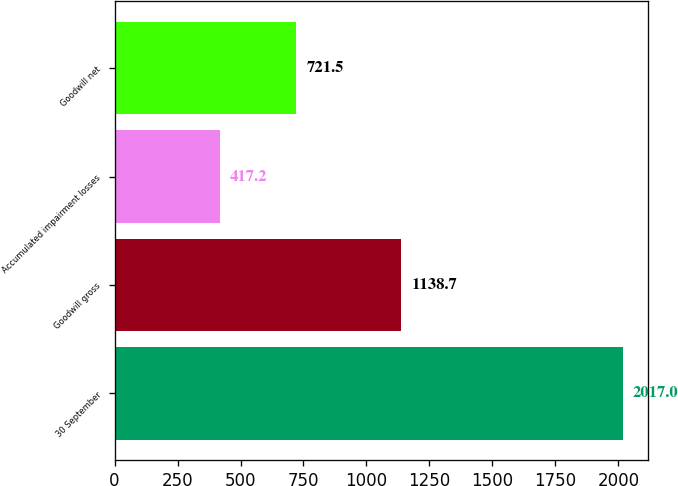Convert chart to OTSL. <chart><loc_0><loc_0><loc_500><loc_500><bar_chart><fcel>30 September<fcel>Goodwill gross<fcel>Accumulated impairment losses<fcel>Goodwill net<nl><fcel>2017<fcel>1138.7<fcel>417.2<fcel>721.5<nl></chart> 